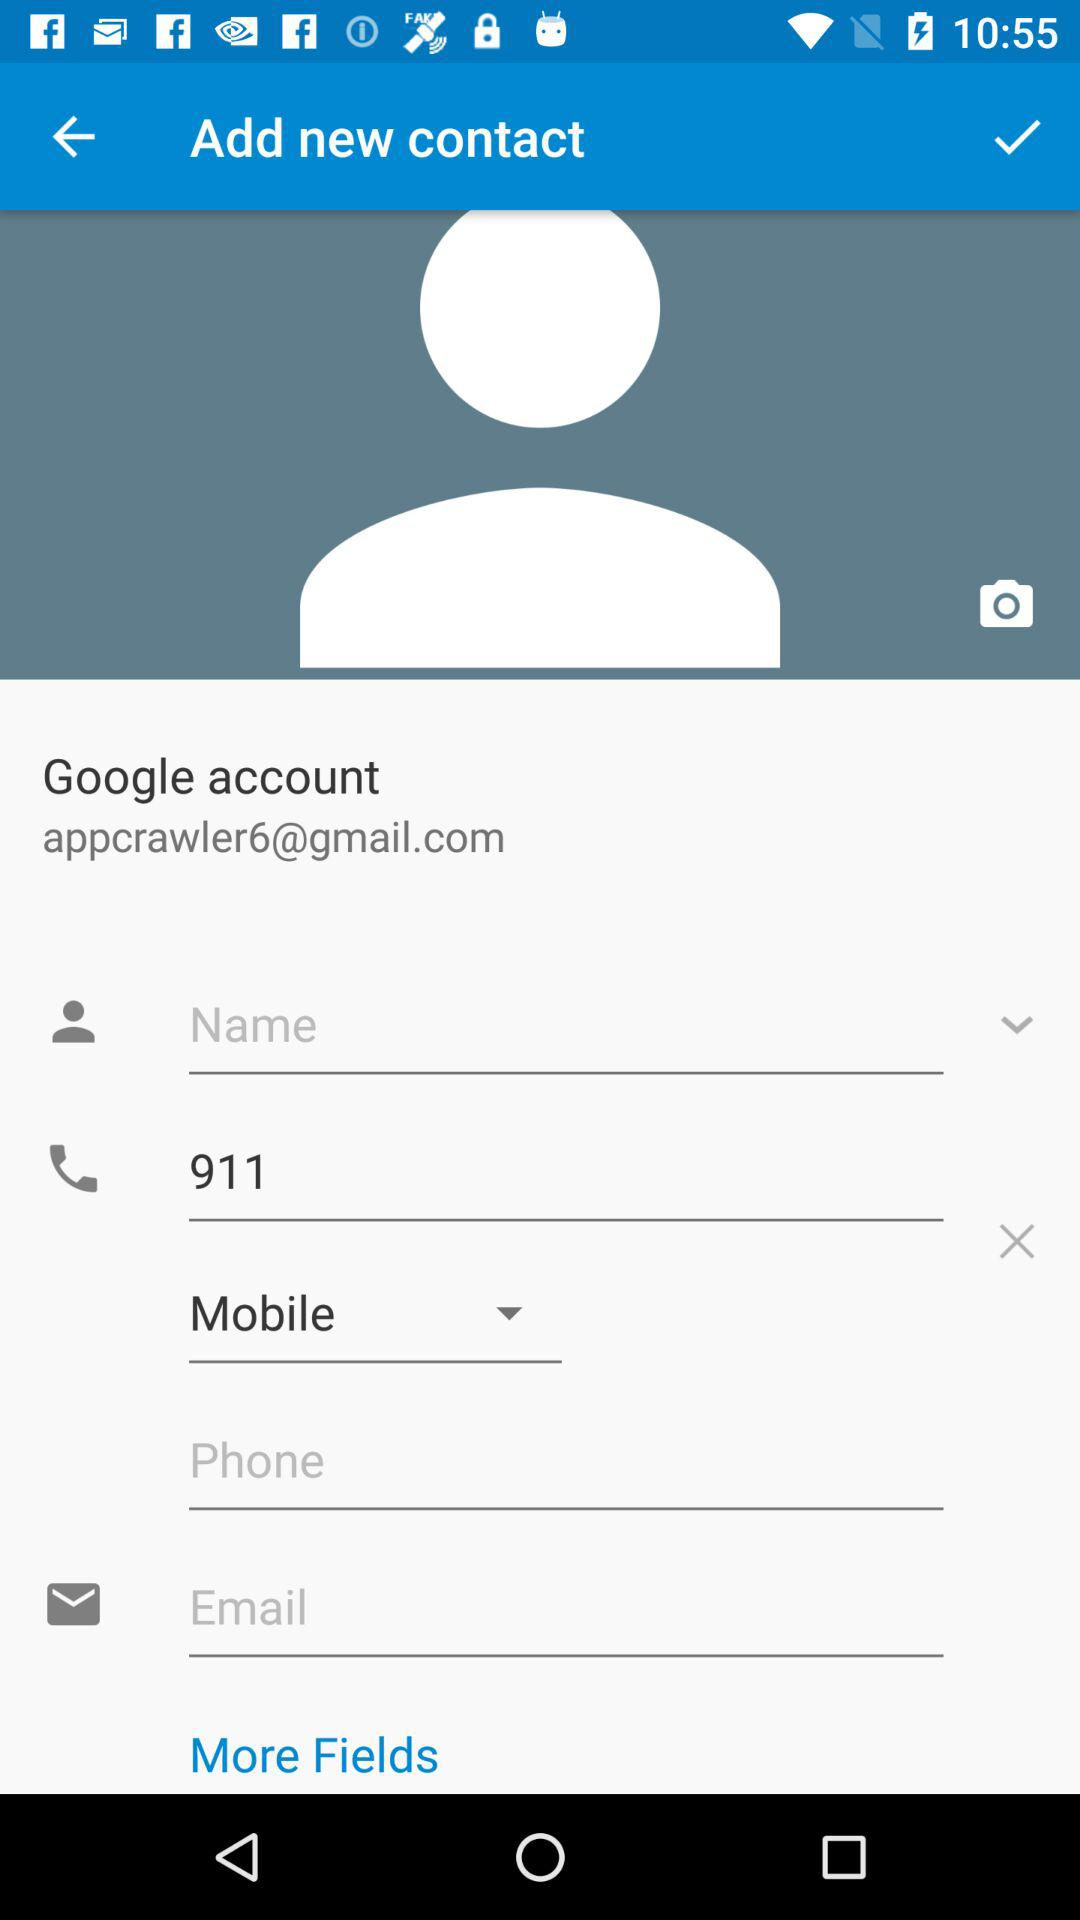What is the phone number?
When the provided information is insufficient, respond with <no answer>. <no answer> 